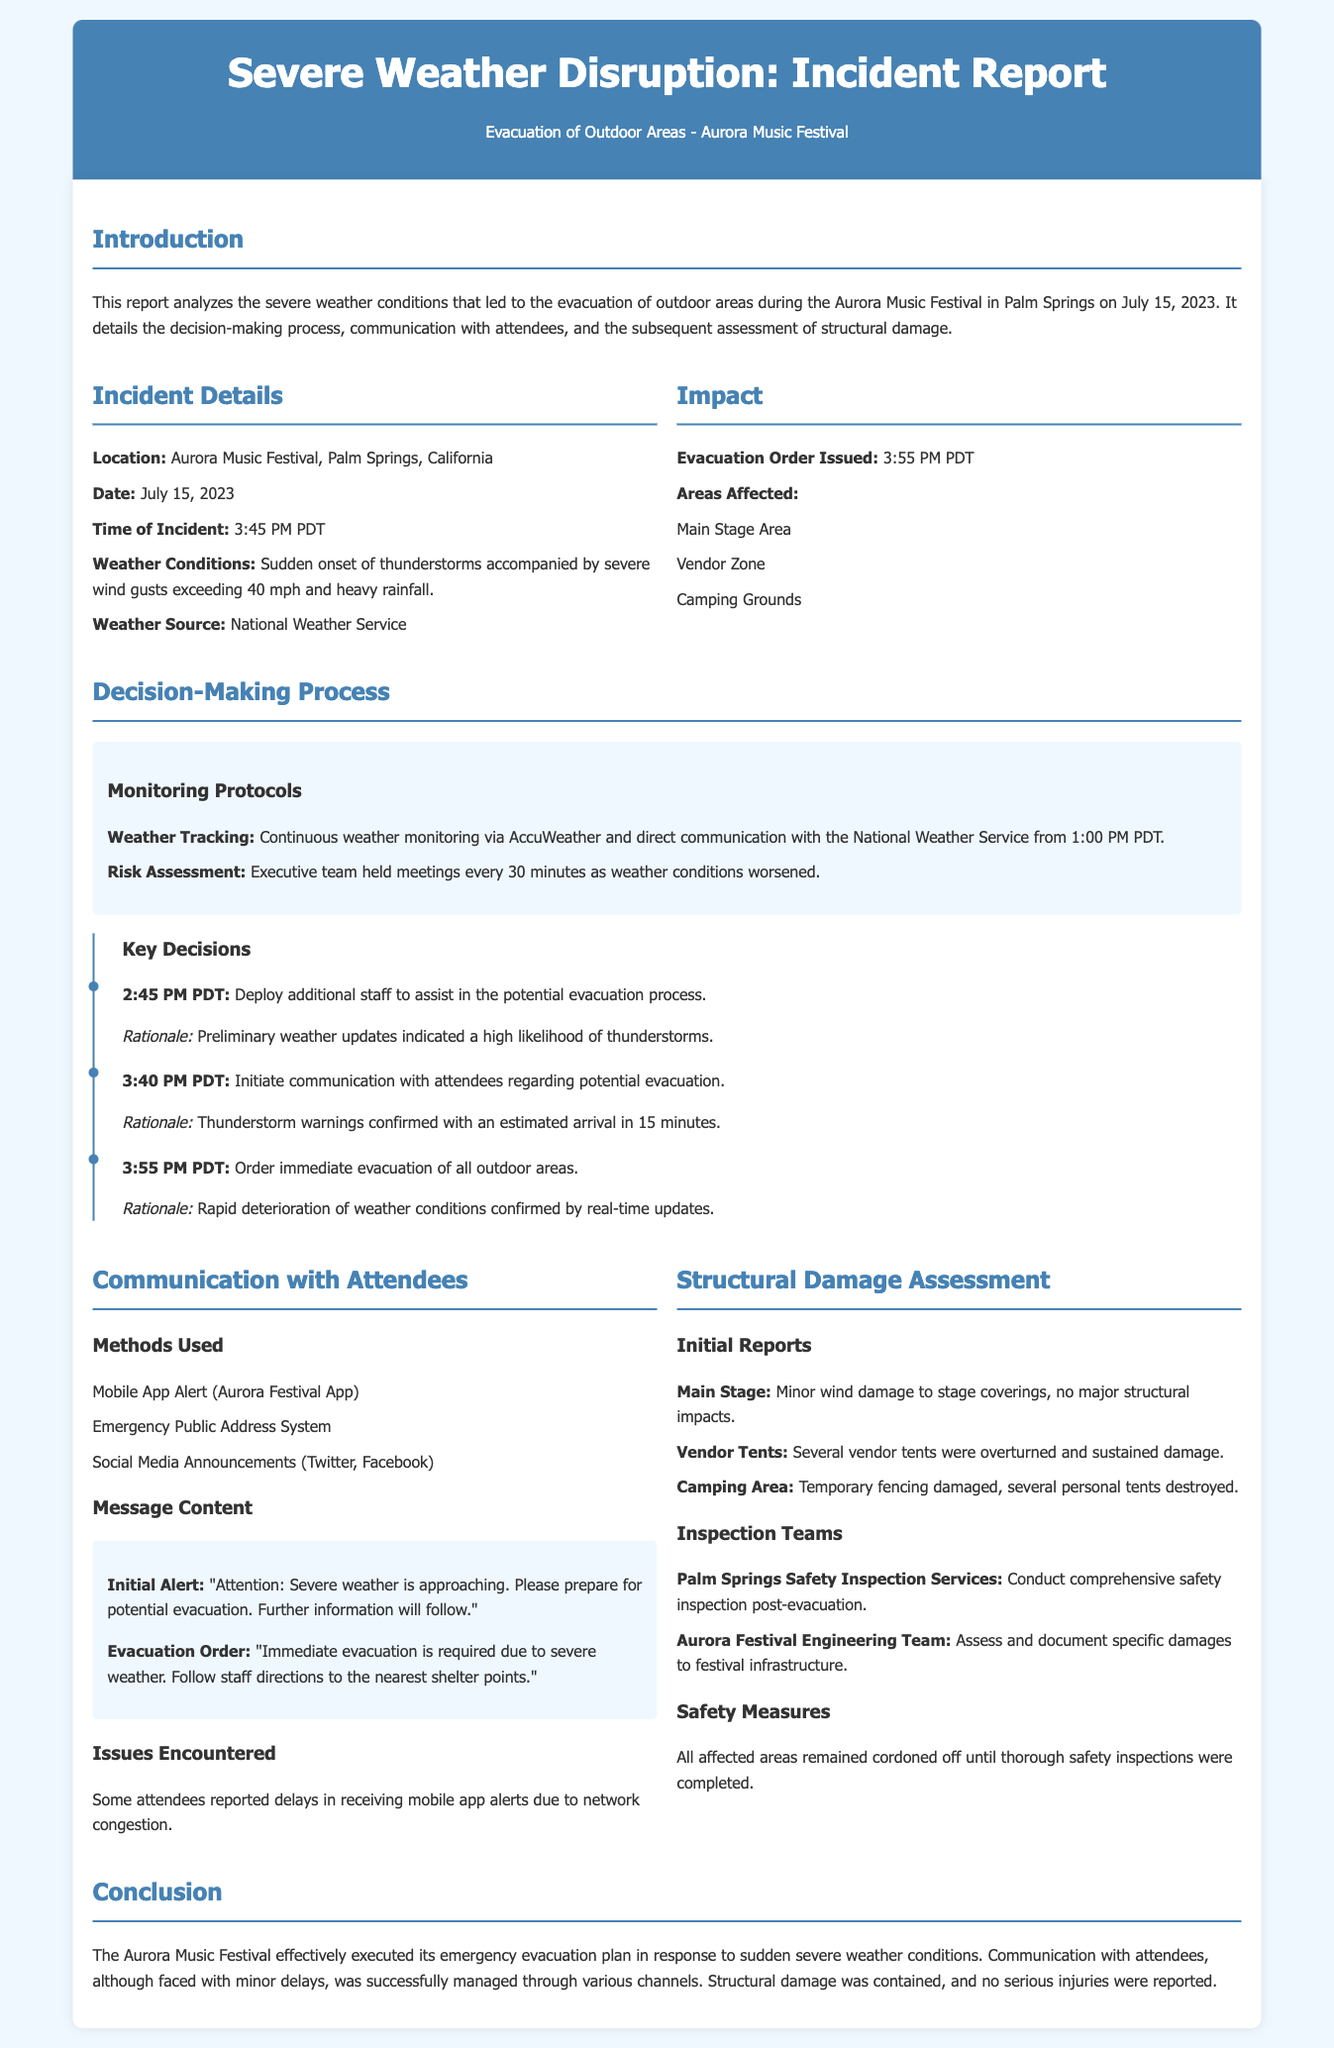What date did the incident occur? The incident occurred on July 15, 2023, as mentioned in the document.
Answer: July 15, 2023 What time was the evacuation order issued? The evacuation order was issued at 3:55 PM PDT according to the incident details.
Answer: 3:55 PM PDT What weather conditions were reported? The weather conditions reported included thunderstorms, severe wind gusts exceeding 40 mph, and heavy rainfall.
Answer: Thunderstorms, severe wind gusts exceeding 40 mph, heavy rainfall What reason was given for the immediate evacuation order? The rationale for the immediate evacuation order was the rapid deterioration of weather conditions confirmed by real-time updates.
Answer: Rapid deterioration of weather conditions Which area sustained minor wind damage? The main stage sustained minor wind damage to stage coverings according to the structural damage assessment.
Answer: Main Stage How were attendees notified about the evacuation? Attendees were notified through mobile app alerts, public address systems, and social media announcements.
Answer: Mobile App Alert, Emergency Public Address System, Social Media Announcements What time was the first communication with attendees regarding potential evacuation? The first communication regarding potential evacuation occurred at 3:40 PM PDT.
Answer: 3:40 PM PDT Who conducted the comprehensive safety inspection post-evacuation? The comprehensive safety inspection post-evacuation was conducted by Palm Springs Safety Inspection Services.
Answer: Palm Springs Safety Inspection Services What measures were taken to ensure safety in affected areas? All affected areas remained cordoned off until thorough safety inspections were completed.
Answer: Cordoned off until inspections completed 